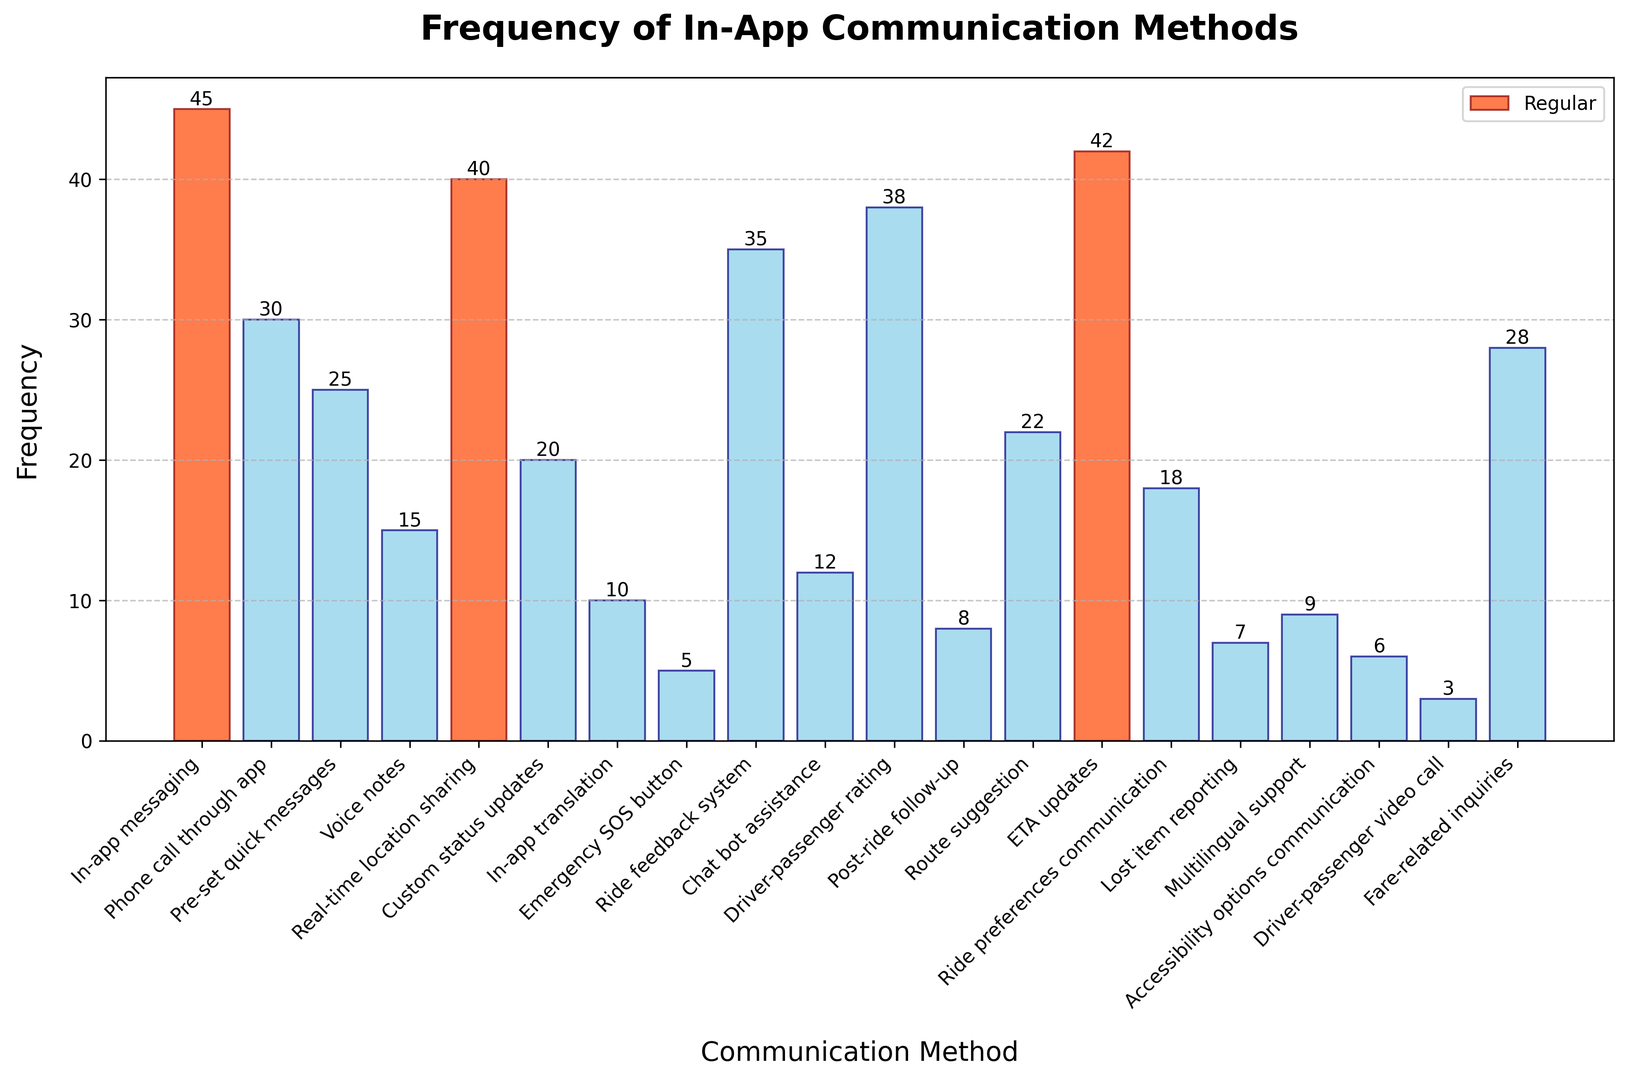What's the most frequently used in-app communication method? The most frequently used in-app communication method can be identified by the tallest bar in the histogram. The bar labeled "In-app messaging" has the greatest height, indicating a frequency of 45.
Answer: In-app messaging (45) Which communication method is used least frequently, and what is its frequency? The least frequently used communication method can be identified by the shortest bar in the histogram. The bar labeled "Driver-passenger video call" has the smallest height, indicating a frequency of 3.
Answer: Driver-passenger video call (3) How many communication methods have a frequency greater than 30? By looking for bars with heights greater than 30 in the histogram, we see the methods: "In-app messaging" (45), "Real-time location sharing" (40), "Ride feedback system" (35), "Driver-passenger rating" (38), and "ETA updates" (42). That makes five methods.
Answer: 5 Which are the top three most frequent communication methods, and what frequencies do they have? The top three communication methods are highlighted in the histogram. "In-app messaging" (45), "ETA updates" (42), and "Real-time location sharing" (40) have the highest frequencies.
Answer: In-app messaging (45), ETA updates (42), Real-time location sharing (40) What's the total frequency of all communication methods combined? To get the total frequency, add the frequencies of all the communication methods: 45 + 30 + 25 + 15 + 40 + 20 + 10 + 5 + 35 + 12 + 38 + 8 + 22 + 42 + 18 + 7 + 9 + 6 + 3 + 28 = 418.
Answer: 418 What's the frequency difference between "In-app messaging" and "Fare-related inquiries"? The frequency of "In-app messaging" is 45, and the frequency of "Fare-related inquiries" is 28. The difference is 45 - 28.
Answer: 17 Are there any communication methods with a frequency equal to 10? By examining the histogram, the method "In-app translation" has a frequency of 10 as indicated by the height of its bar.
Answer: In-app translation (10) What is the average frequency of the communication methods with "updates" in their name? The communication methods with "updates" in their name are "ETA updates" (42) and "Custom status updates" (20). To find the average: (42 + 20) / 2 = 31.
Answer: 31 Among "Phone call through app", "Ride preferences communication", and "Lost item reporting", which method has the highest frequency, and what is that frequency? By comparing the bar heights of these methods, "Phone call through app" has the highest frequency with a value of 30.
Answer: Phone call through app (30) What's the sum of frequencies of the least three frequent communication methods? The least frequent methods are "Driver-passenger video call" (3), "Emergency SOS button" (5), and "Accessibility options communication" (6). Adding these gives: 3 + 5 + 6 = 14.
Answer: 14 